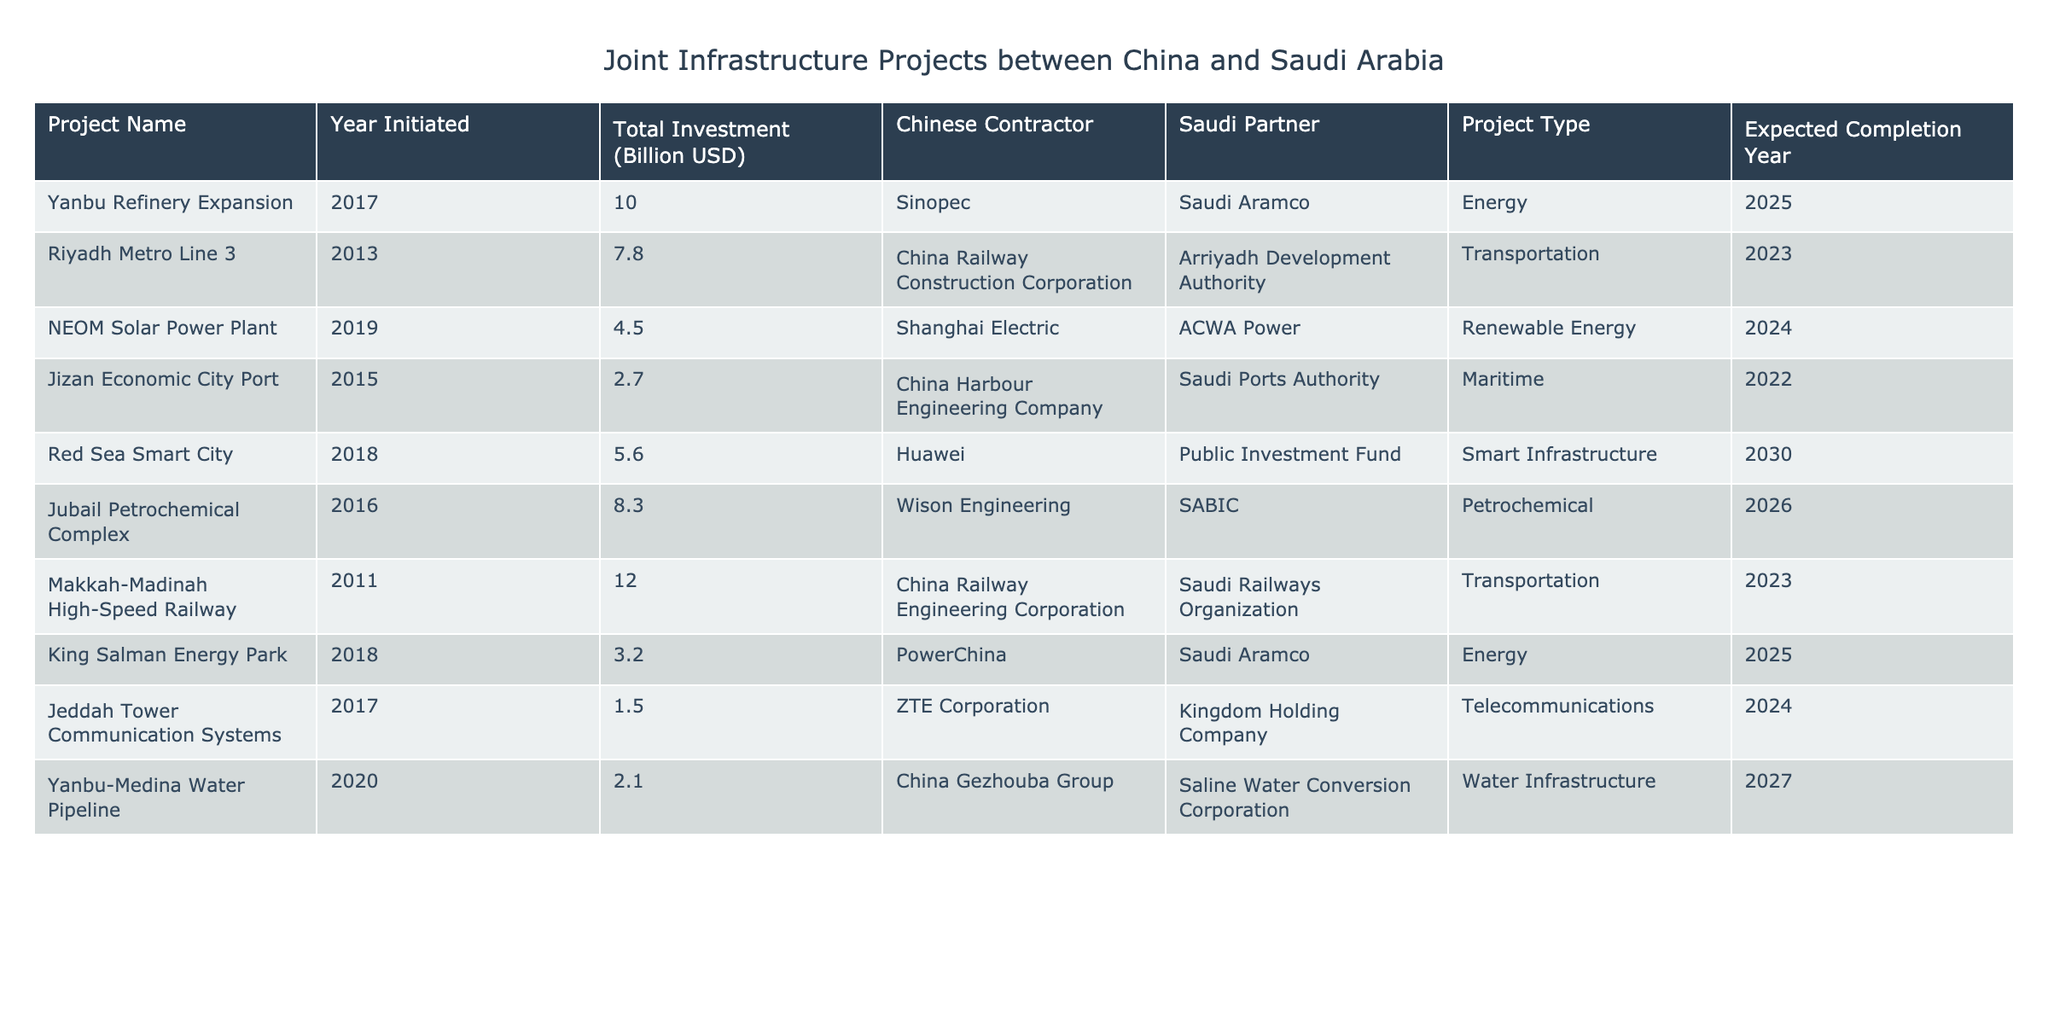What is the total investment for the NEOM Solar Power Plant? The NEOM Solar Power Plant is listed in the table, and the corresponding total investment is mentioned as 4.5 billion USD.
Answer: 4.5 billion USD Which project has the highest expected completion year? To find this, I looked at the "Expected Completion Year" column and identified the maximum year, which is 2030 for the Red Sea Smart City project.
Answer: 2030 How many projects involve Saudi Aramco as a partner? By checking the "Saudi Partner" column, Saudi Aramco appears in the Yanbu Refinery Expansion and the King Salman Energy Park projects, which totals to two projects.
Answer: 2 What is the total investment for all projects listed in the table? The total investment can be calculated by summing the Total Investment column: 10.0 + 7.8 + 4.5 + 2.7 + 5.6 + 8.3 + 12.0 + 3.2 + 1.5 + 2.1 = 54.7 billion USD.
Answer: 54.7 billion USD Are there any projects that are expected to complete in 2024? Checking the "Expected Completion Year" column, the NEOM Solar Power Plant and Jeddah Tower Communication Systems both show 2024 as their expected completion year.
Answer: Yes What is the average total investment of the transportation projects? The transportation projects are Riyadh Metro Line 3 and Makkah-Madinah High-Speed Railway, with investments of 7.8 and 12.0 billion USD, respectively. The average is (7.8 + 12.0) / 2 = 9.9 billion USD.
Answer: 9.9 billion USD Which project initiated in 2011 has the highest investment? The only project initiated in 2011 is the Makkah-Madinah High-Speed Railway, which has an investment of 12.0 billion USD, making it the highest for that year.
Answer: Makkah-Madinah High-Speed Railway Is there a project that combines telecommunications and Chinese contractors? Looking at the "Project Type" and "Chinese Contractor" columns, the Jeddah Tower Communication Systems project is indeed a telecommunications project with ZTE Corporation as the Chinese contractor.
Answer: Yes Which project has the second highest total investment and what is its value? Sorting the total investments reveals that the Makkah-Madinah High-Speed Railway has the highest at 12.0 billion USD, while the Yanbu Refinery Expansion, the second highest, has 10.0 billion USD.
Answer: 10.0 billion USD What types of projects are represented in this table? I can identify the projects in the table as follows: Energy, Transportation, Renewable Energy, Maritime, Smart Infrastructure, Petrochemical, and Water Infrastructure, indicating a diverse range.
Answer: 7 types 